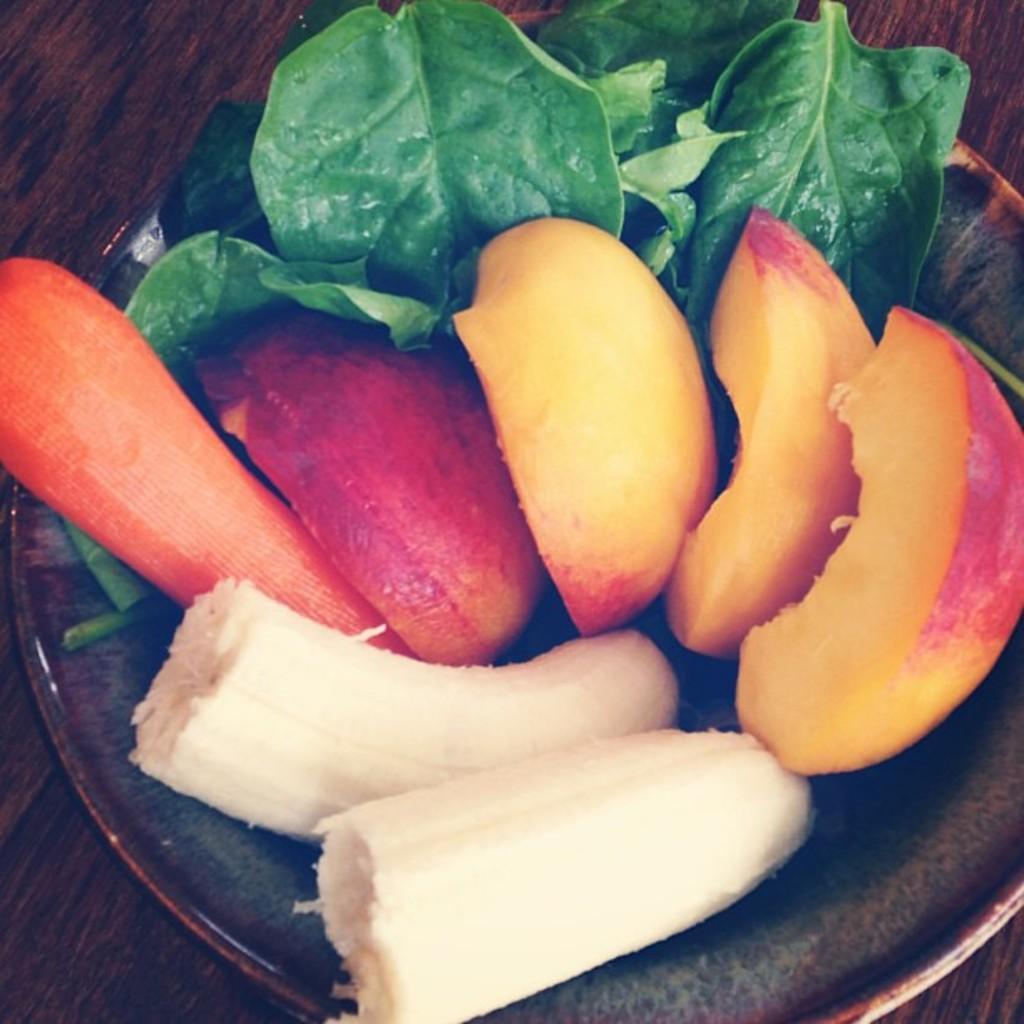How would you summarize this image in a sentence or two? In this image I can see a plate and in it I can see four pieces of an apple, two pieces of a banana and a carrot like thing. I can also see few green leaves. 